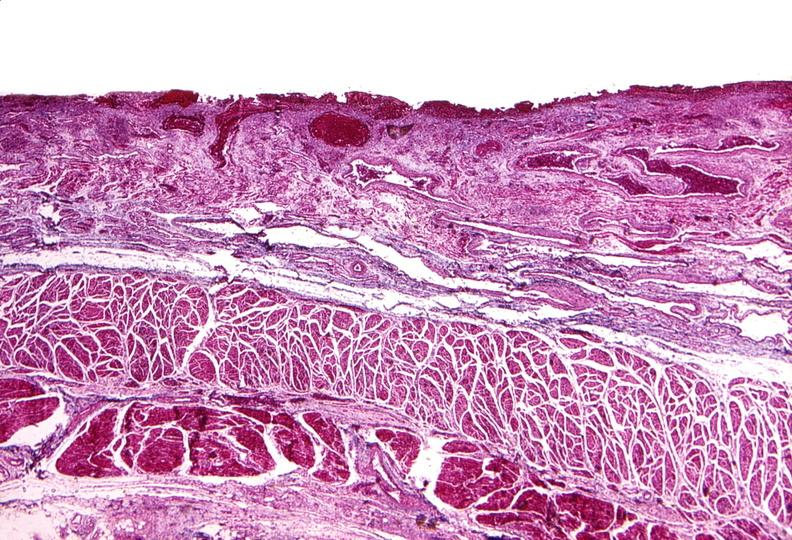s heel ulcer present?
Answer the question using a single word or phrase. No 